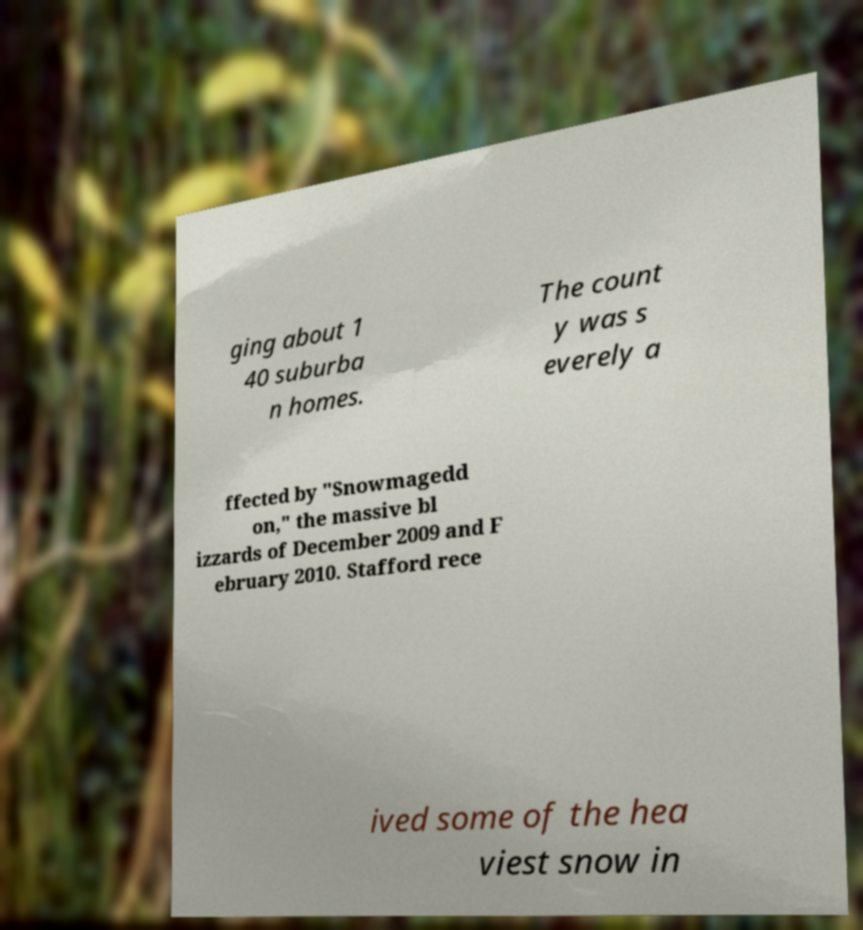Could you assist in decoding the text presented in this image and type it out clearly? ging about 1 40 suburba n homes. The count y was s everely a ffected by "Snowmagedd on," the massive bl izzards of December 2009 and F ebruary 2010. Stafford rece ived some of the hea viest snow in 